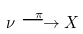<formula> <loc_0><loc_0><loc_500><loc_500>\nu \stackrel { \pi } { \longrightarrow } X</formula> 